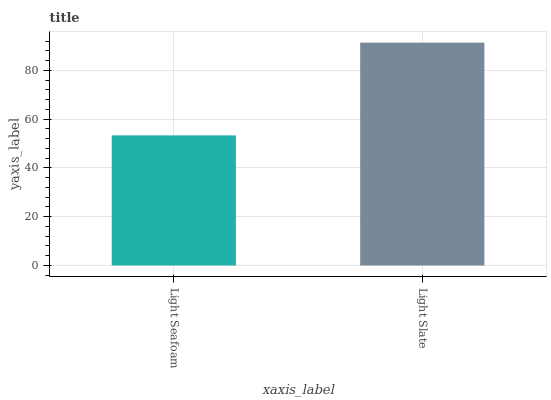Is Light Seafoam the minimum?
Answer yes or no. Yes. Is Light Slate the maximum?
Answer yes or no. Yes. Is Light Slate the minimum?
Answer yes or no. No. Is Light Slate greater than Light Seafoam?
Answer yes or no. Yes. Is Light Seafoam less than Light Slate?
Answer yes or no. Yes. Is Light Seafoam greater than Light Slate?
Answer yes or no. No. Is Light Slate less than Light Seafoam?
Answer yes or no. No. Is Light Slate the high median?
Answer yes or no. Yes. Is Light Seafoam the low median?
Answer yes or no. Yes. Is Light Seafoam the high median?
Answer yes or no. No. Is Light Slate the low median?
Answer yes or no. No. 